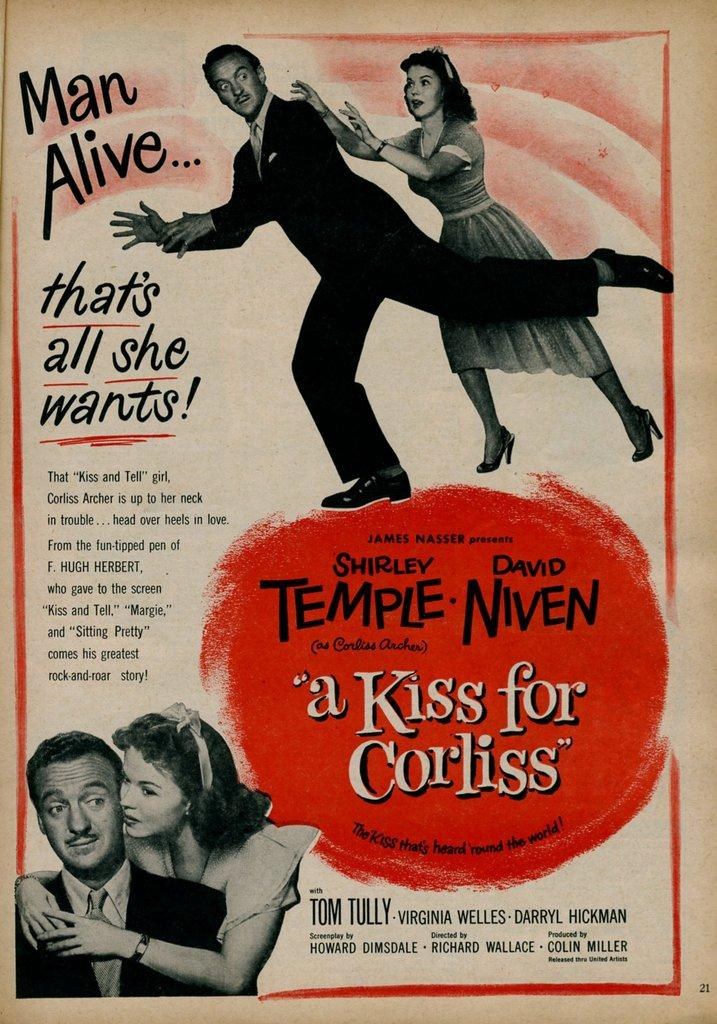<image>
Provide a brief description of the given image. The poster advertises a movie starring David Niven and Shirley Temple. 